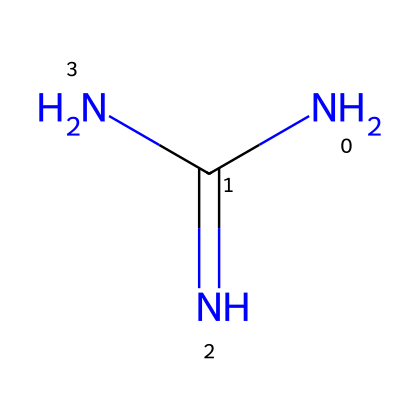What is the molecular formula of this chemical? The SMILES representation indicates that there are one nitrogen atom from each of the three nitrogen symbols (N), one carbon atom (C), and also an oxygen atom (O) from the carbon's double bond with nitrogen (N). Thus, the total count gives the molecular formula C1H7N5.
Answer: C1H7N5 How many nitrogen atoms are present in guanidine? In the structural formula indicated by the SMILES, there are three nitrogen (N) atoms. Each nitrogen atom is counted from its individual symbols in the representation.
Answer: 3 What type of chemical is guanidine? Guanidine is classified as a superbase due to its ability to accept protons easily and its strong basic nature. It has an amino structure, indicating it can act as a base.
Answer: superbase What functional group is present in guanidine? The presence of the -NH2 group in the structure indicates that guanidine contains an amine functional group. This is identified based on nitrogen atoms bonded to hydrogen.
Answer: amine Is guanidine soluble in water? Guanidine is highly soluble in water due to its polar nature and ability to form hydrogen bonds through its amine groups, which interact favorably with water molecules.
Answer: yes What is the pKa value of guanidine? The pKa value of guanidine is approximately 13.6, indicating that it readily accepts protons and showcases its strength as a superbase. A value above 12 generally signifies strong basicity.
Answer: 13.6 